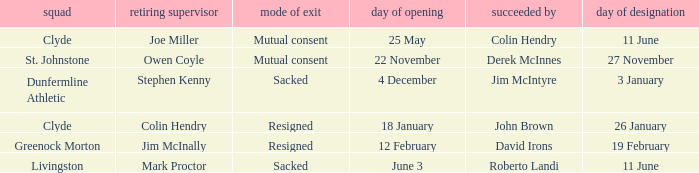I want to know the team that was sacked and date of vacancy was 4 december Dunfermline Athletic. 